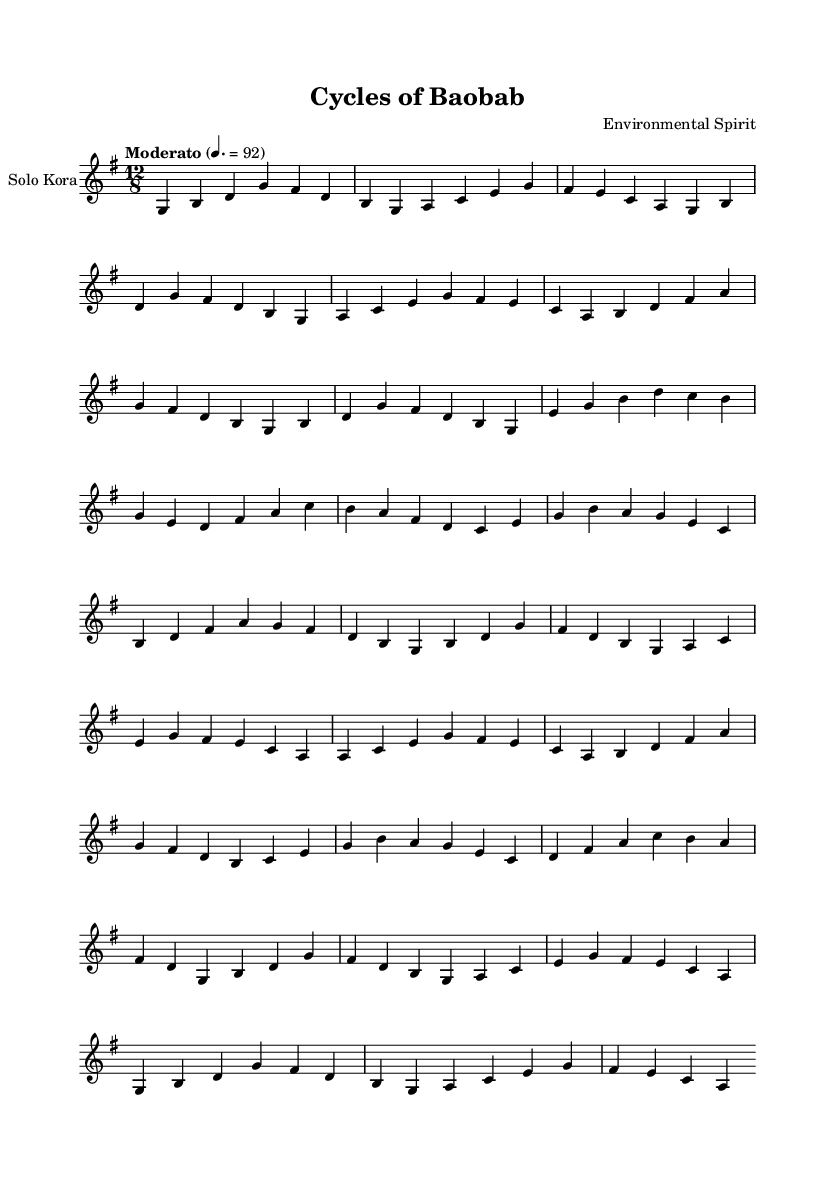What is the key signature of this music? The key signature is G major, which contains one sharp (F#). This can be determined by looking at the key signature indicated at the beginning of the score.
Answer: G major What is the time signature of the piece? The time signature is 12/8, which shows that there are 12 beats in a measure and the eighth note gets one beat. This is indicated in the beginning of the score.
Answer: 12/8 What is the tempo marking for this piece? The tempo marking is Moderato, indicated as 4 equals 92. This specifies a moderate speed for the piece.
Answer: Moderato How many distinct sections are in this piece? There are five distinct sections identified as Intro, A, B, C, and Outro in the music. Each section has different musical ideas or variations, contributing to the overall form.
Answer: Five What is the range of the kora melody in this piece? The range of the kora melody extends from G to high D, which is determined by the lowest and highest notes presented in the melodic line. This can be observed from the notes written in the staff.
Answer: G to high D Which two sections are shortened versions of section A? Sections A' and A'' are both shortened versions of section A. They retain elements of the original A section while being condensed, as indicated by their notation and placement in the score.
Answer: A' and A'' 